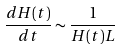Convert formula to latex. <formula><loc_0><loc_0><loc_500><loc_500>\frac { d H ( t ) } { d t } \sim \frac { 1 } { H ( t ) L }</formula> 